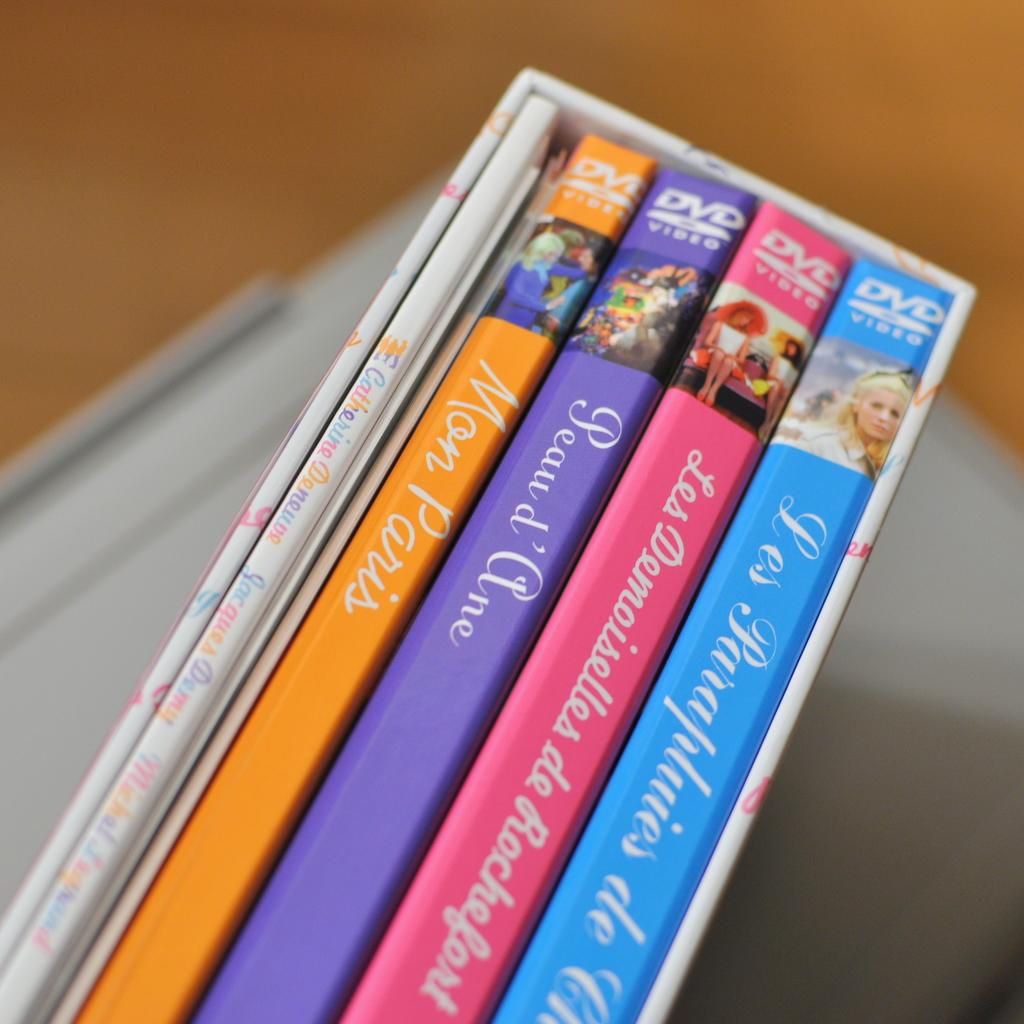<image>
Write a terse but informative summary of the picture. The set of DVD videos includes the title Mon Paris. 